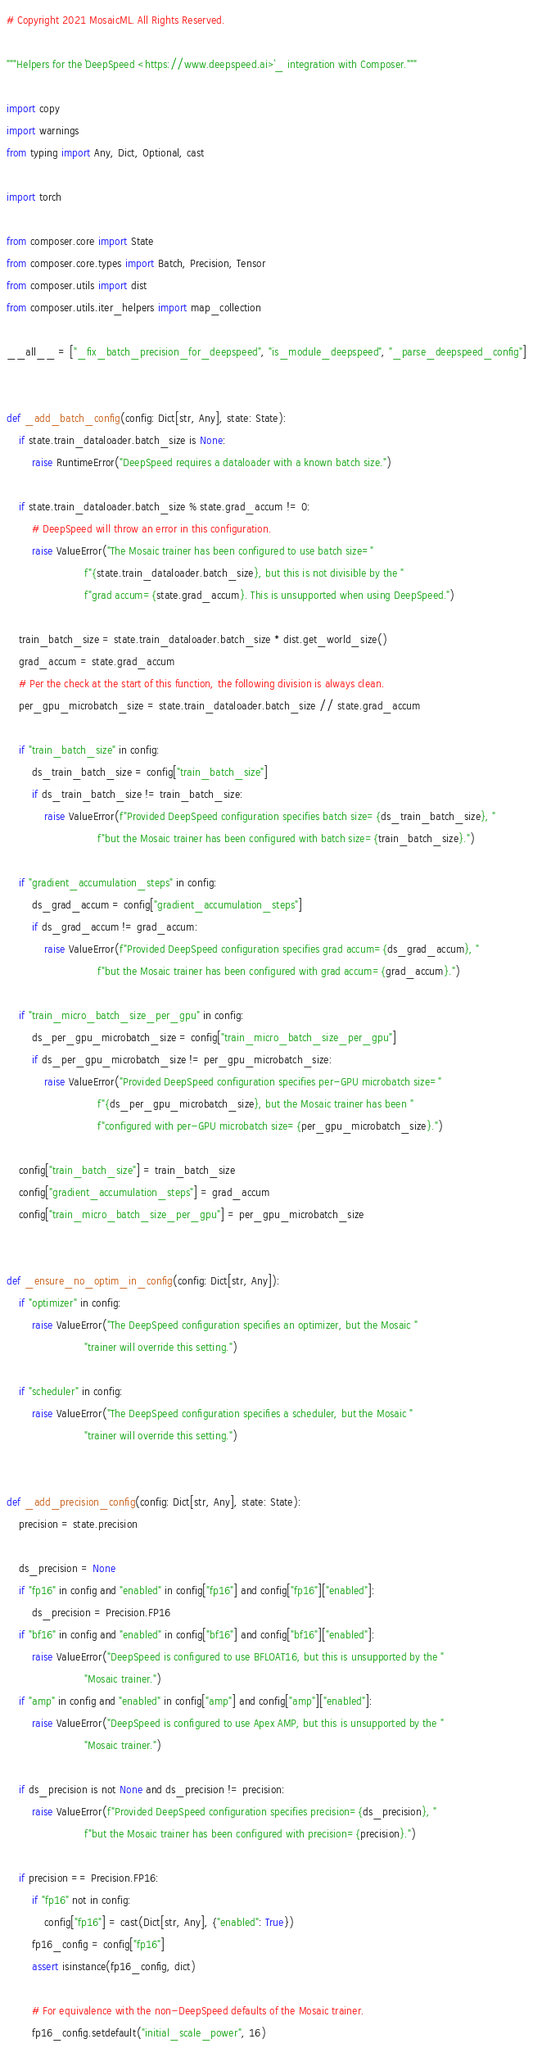Convert code to text. <code><loc_0><loc_0><loc_500><loc_500><_Python_># Copyright 2021 MosaicML. All Rights Reserved.

"""Helpers for the `DeepSpeed <https://www.deepspeed.ai>`_ integration with Composer."""

import copy
import warnings
from typing import Any, Dict, Optional, cast

import torch

from composer.core import State
from composer.core.types import Batch, Precision, Tensor
from composer.utils import dist
from composer.utils.iter_helpers import map_collection

__all__ = ["_fix_batch_precision_for_deepspeed", "is_module_deepspeed", "_parse_deepspeed_config"]


def _add_batch_config(config: Dict[str, Any], state: State):
    if state.train_dataloader.batch_size is None:
        raise RuntimeError("DeepSpeed requires a dataloader with a known batch size.")

    if state.train_dataloader.batch_size % state.grad_accum != 0:
        # DeepSpeed will throw an error in this configuration.
        raise ValueError("The Mosaic trainer has been configured to use batch size="
                         f"{state.train_dataloader.batch_size}, but this is not divisible by the "
                         f"grad accum={state.grad_accum}. This is unsupported when using DeepSpeed.")

    train_batch_size = state.train_dataloader.batch_size * dist.get_world_size()
    grad_accum = state.grad_accum
    # Per the check at the start of this function, the following division is always clean.
    per_gpu_microbatch_size = state.train_dataloader.batch_size // state.grad_accum

    if "train_batch_size" in config:
        ds_train_batch_size = config["train_batch_size"]
        if ds_train_batch_size != train_batch_size:
            raise ValueError(f"Provided DeepSpeed configuration specifies batch size={ds_train_batch_size}, "
                             f"but the Mosaic trainer has been configured with batch size={train_batch_size}.")

    if "gradient_accumulation_steps" in config:
        ds_grad_accum = config["gradient_accumulation_steps"]
        if ds_grad_accum != grad_accum:
            raise ValueError(f"Provided DeepSpeed configuration specifies grad accum={ds_grad_accum}, "
                             f"but the Mosaic trainer has been configured with grad accum={grad_accum}.")

    if "train_micro_batch_size_per_gpu" in config:
        ds_per_gpu_microbatch_size = config["train_micro_batch_size_per_gpu"]
        if ds_per_gpu_microbatch_size != per_gpu_microbatch_size:
            raise ValueError("Provided DeepSpeed configuration specifies per-GPU microbatch size="
                             f"{ds_per_gpu_microbatch_size}, but the Mosaic trainer has been "
                             f"configured with per-GPU microbatch size={per_gpu_microbatch_size}.")

    config["train_batch_size"] = train_batch_size
    config["gradient_accumulation_steps"] = grad_accum
    config["train_micro_batch_size_per_gpu"] = per_gpu_microbatch_size


def _ensure_no_optim_in_config(config: Dict[str, Any]):
    if "optimizer" in config:
        raise ValueError("The DeepSpeed configuration specifies an optimizer, but the Mosaic "
                         "trainer will override this setting.")

    if "scheduler" in config:
        raise ValueError("The DeepSpeed configuration specifies a scheduler, but the Mosaic "
                         "trainer will override this setting.")


def _add_precision_config(config: Dict[str, Any], state: State):
    precision = state.precision

    ds_precision = None
    if "fp16" in config and "enabled" in config["fp16"] and config["fp16"]["enabled"]:
        ds_precision = Precision.FP16
    if "bf16" in config and "enabled" in config["bf16"] and config["bf16"]["enabled"]:
        raise ValueError("DeepSpeed is configured to use BFLOAT16, but this is unsupported by the "
                         "Mosaic trainer.")
    if "amp" in config and "enabled" in config["amp"] and config["amp"]["enabled"]:
        raise ValueError("DeepSpeed is configured to use Apex AMP, but this is unsupported by the "
                         "Mosaic trainer.")

    if ds_precision is not None and ds_precision != precision:
        raise ValueError(f"Provided DeepSpeed configuration specifies precision={ds_precision}, "
                         f"but the Mosaic trainer has been configured with precision={precision}.")

    if precision == Precision.FP16:
        if "fp16" not in config:
            config["fp16"] = cast(Dict[str, Any], {"enabled": True})
        fp16_config = config["fp16"]
        assert isinstance(fp16_config, dict)

        # For equivalence with the non-DeepSpeed defaults of the Mosaic trainer.
        fp16_config.setdefault("initial_scale_power", 16)</code> 